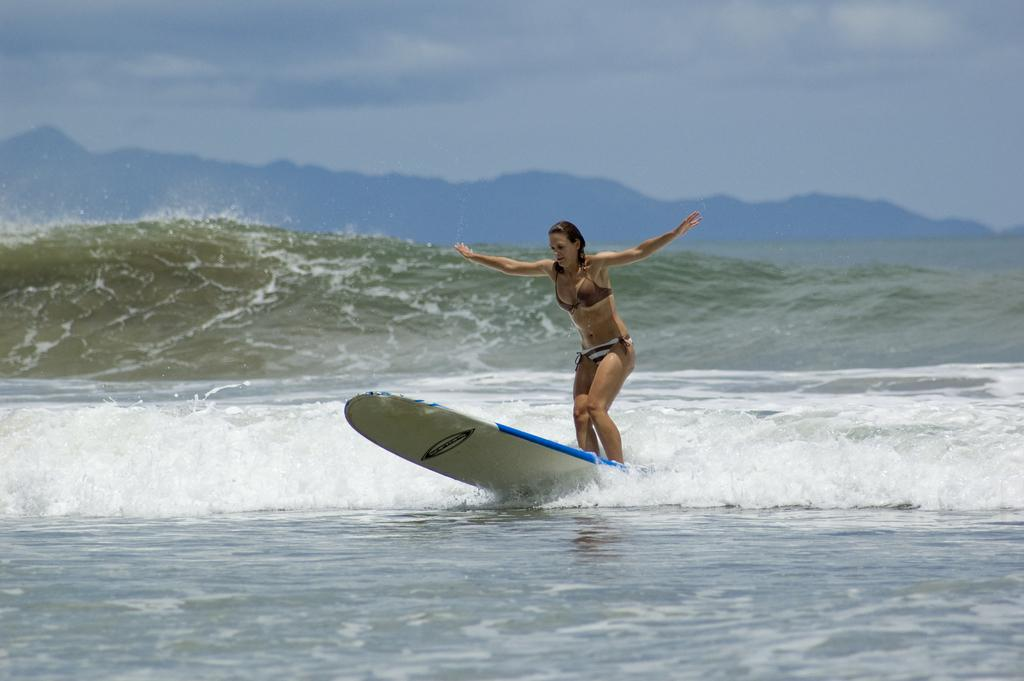Who is the main subject in the image? There is a woman in the image. What is the woman doing in the image? The woman is standing on a surfing board. Where is the surfing board located? The surfing board is in an ocean. What shape is the bone that the woman is holding in the image? There is no bone present in the image; the woman is standing on a surfing board in an ocean. 